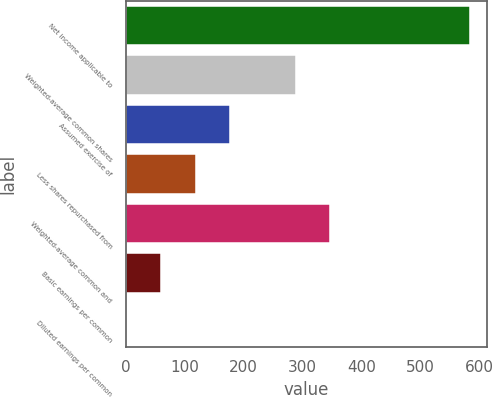<chart> <loc_0><loc_0><loc_500><loc_500><bar_chart><fcel>Net income applicable to<fcel>Weighted-average common shares<fcel>Assumed exercise of<fcel>Less shares repurchased from<fcel>Weighted-average common and<fcel>Basic earnings per common<fcel>Diluted earnings per common<nl><fcel>584<fcel>289<fcel>176.59<fcel>118.39<fcel>347.2<fcel>60.19<fcel>1.99<nl></chart> 